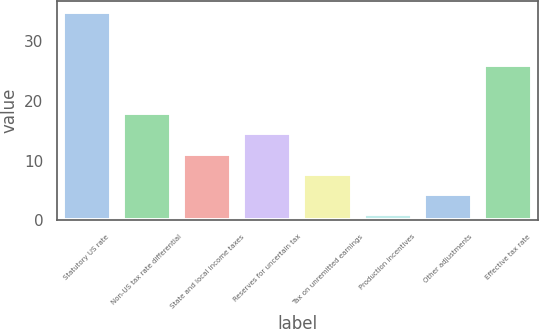Convert chart to OTSL. <chart><loc_0><loc_0><loc_500><loc_500><bar_chart><fcel>Statutory US rate<fcel>Non-US tax rate differential<fcel>State and local income taxes<fcel>Reserves for uncertain tax<fcel>Tax on unremitted earnings<fcel>Production incentives<fcel>Other adjustments<fcel>Effective tax rate<nl><fcel>35<fcel>18<fcel>11.2<fcel>14.6<fcel>7.8<fcel>1<fcel>4.4<fcel>26.1<nl></chart> 